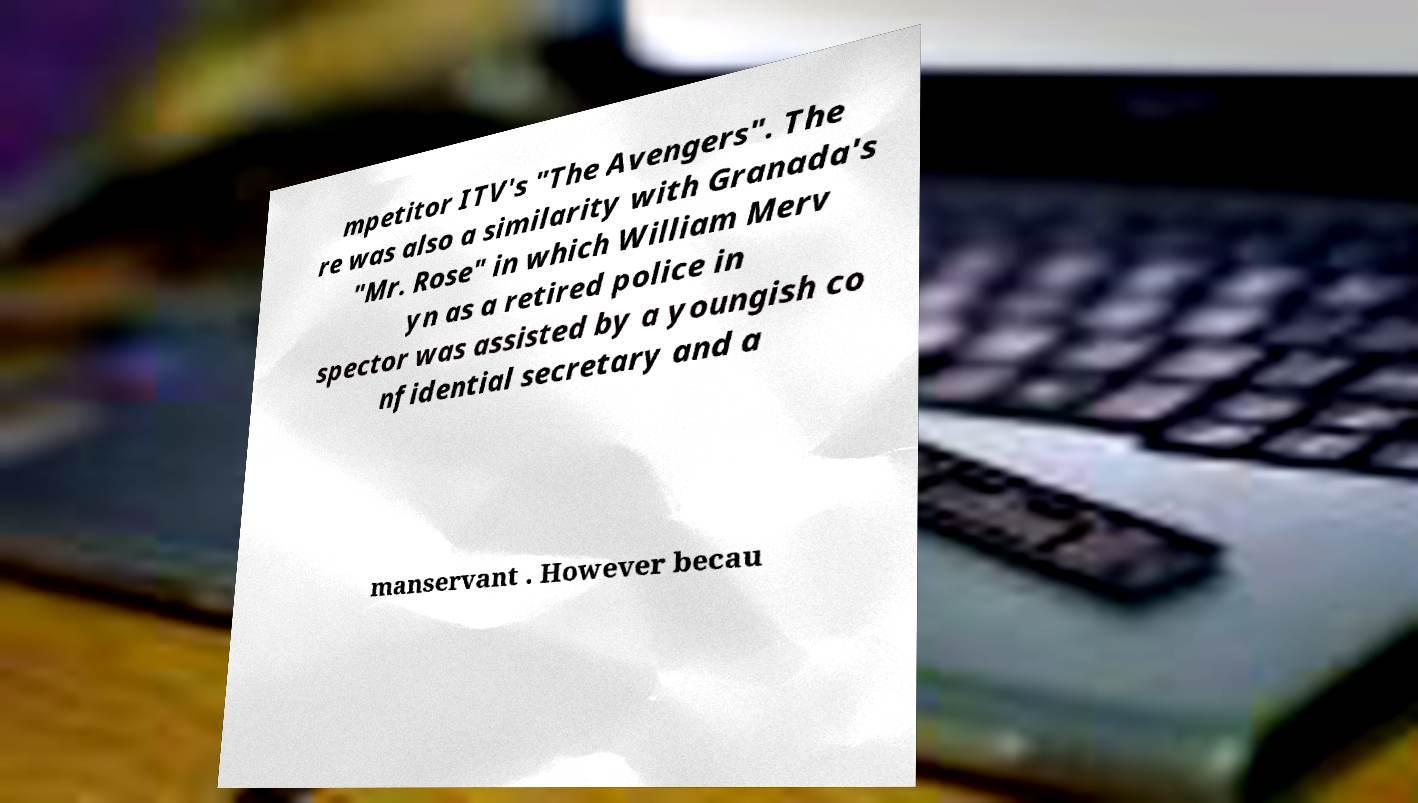Please identify and transcribe the text found in this image. mpetitor ITV's "The Avengers". The re was also a similarity with Granada's "Mr. Rose" in which William Merv yn as a retired police in spector was assisted by a youngish co nfidential secretary and a manservant . However becau 